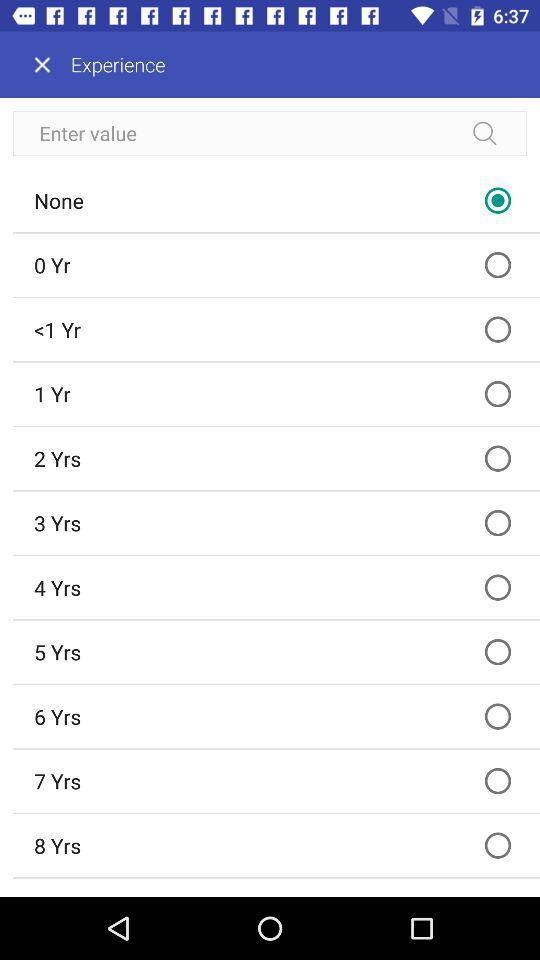What is the status of eight years? The status is "off". 